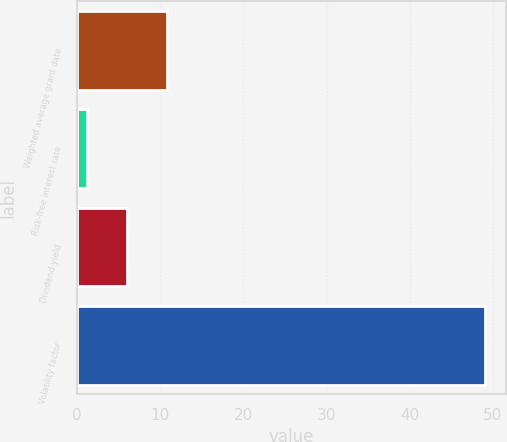Convert chart to OTSL. <chart><loc_0><loc_0><loc_500><loc_500><bar_chart><fcel>Weighted average grant date<fcel>Risk-free interest rate<fcel>Dividend yield<fcel>Volatility factor<nl><fcel>10.79<fcel>1.22<fcel>6<fcel>49.07<nl></chart> 